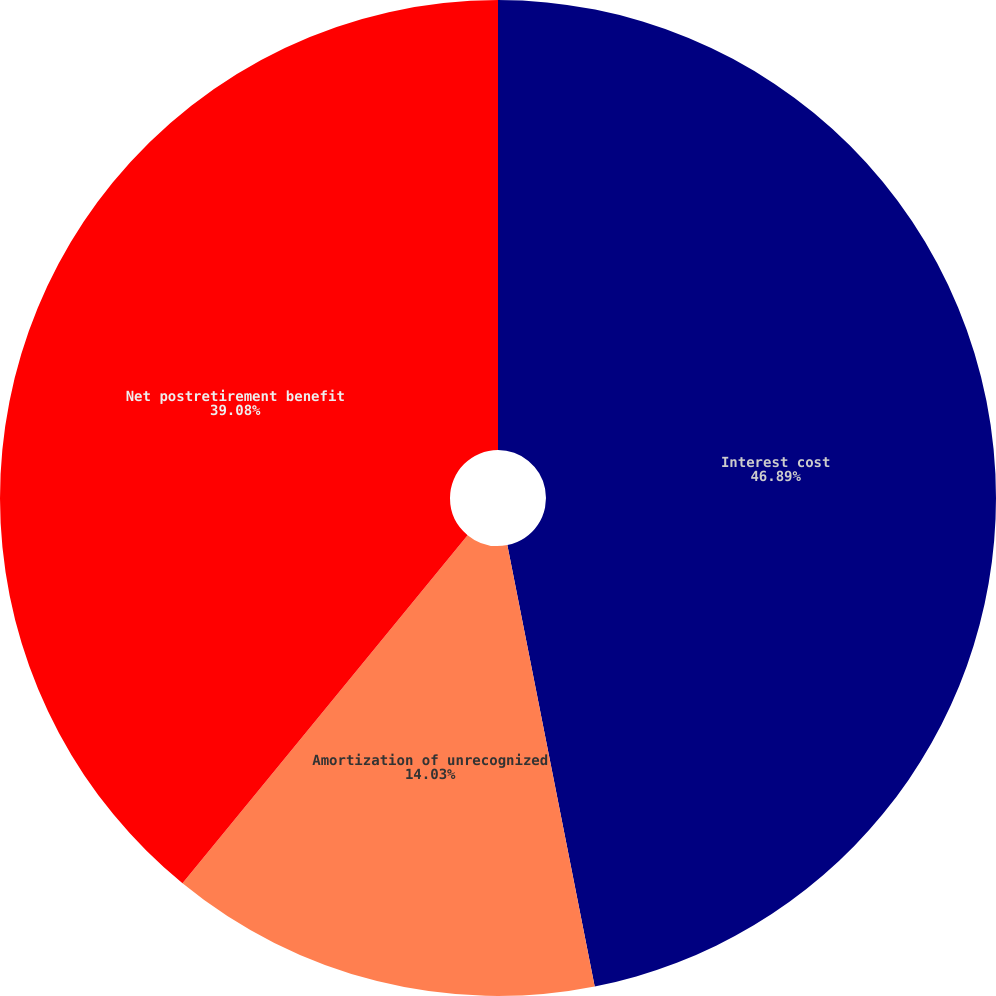Convert chart. <chart><loc_0><loc_0><loc_500><loc_500><pie_chart><fcel>Interest cost<fcel>Amortization of unrecognized<fcel>Net postretirement benefit<nl><fcel>46.89%<fcel>14.03%<fcel>39.08%<nl></chart> 